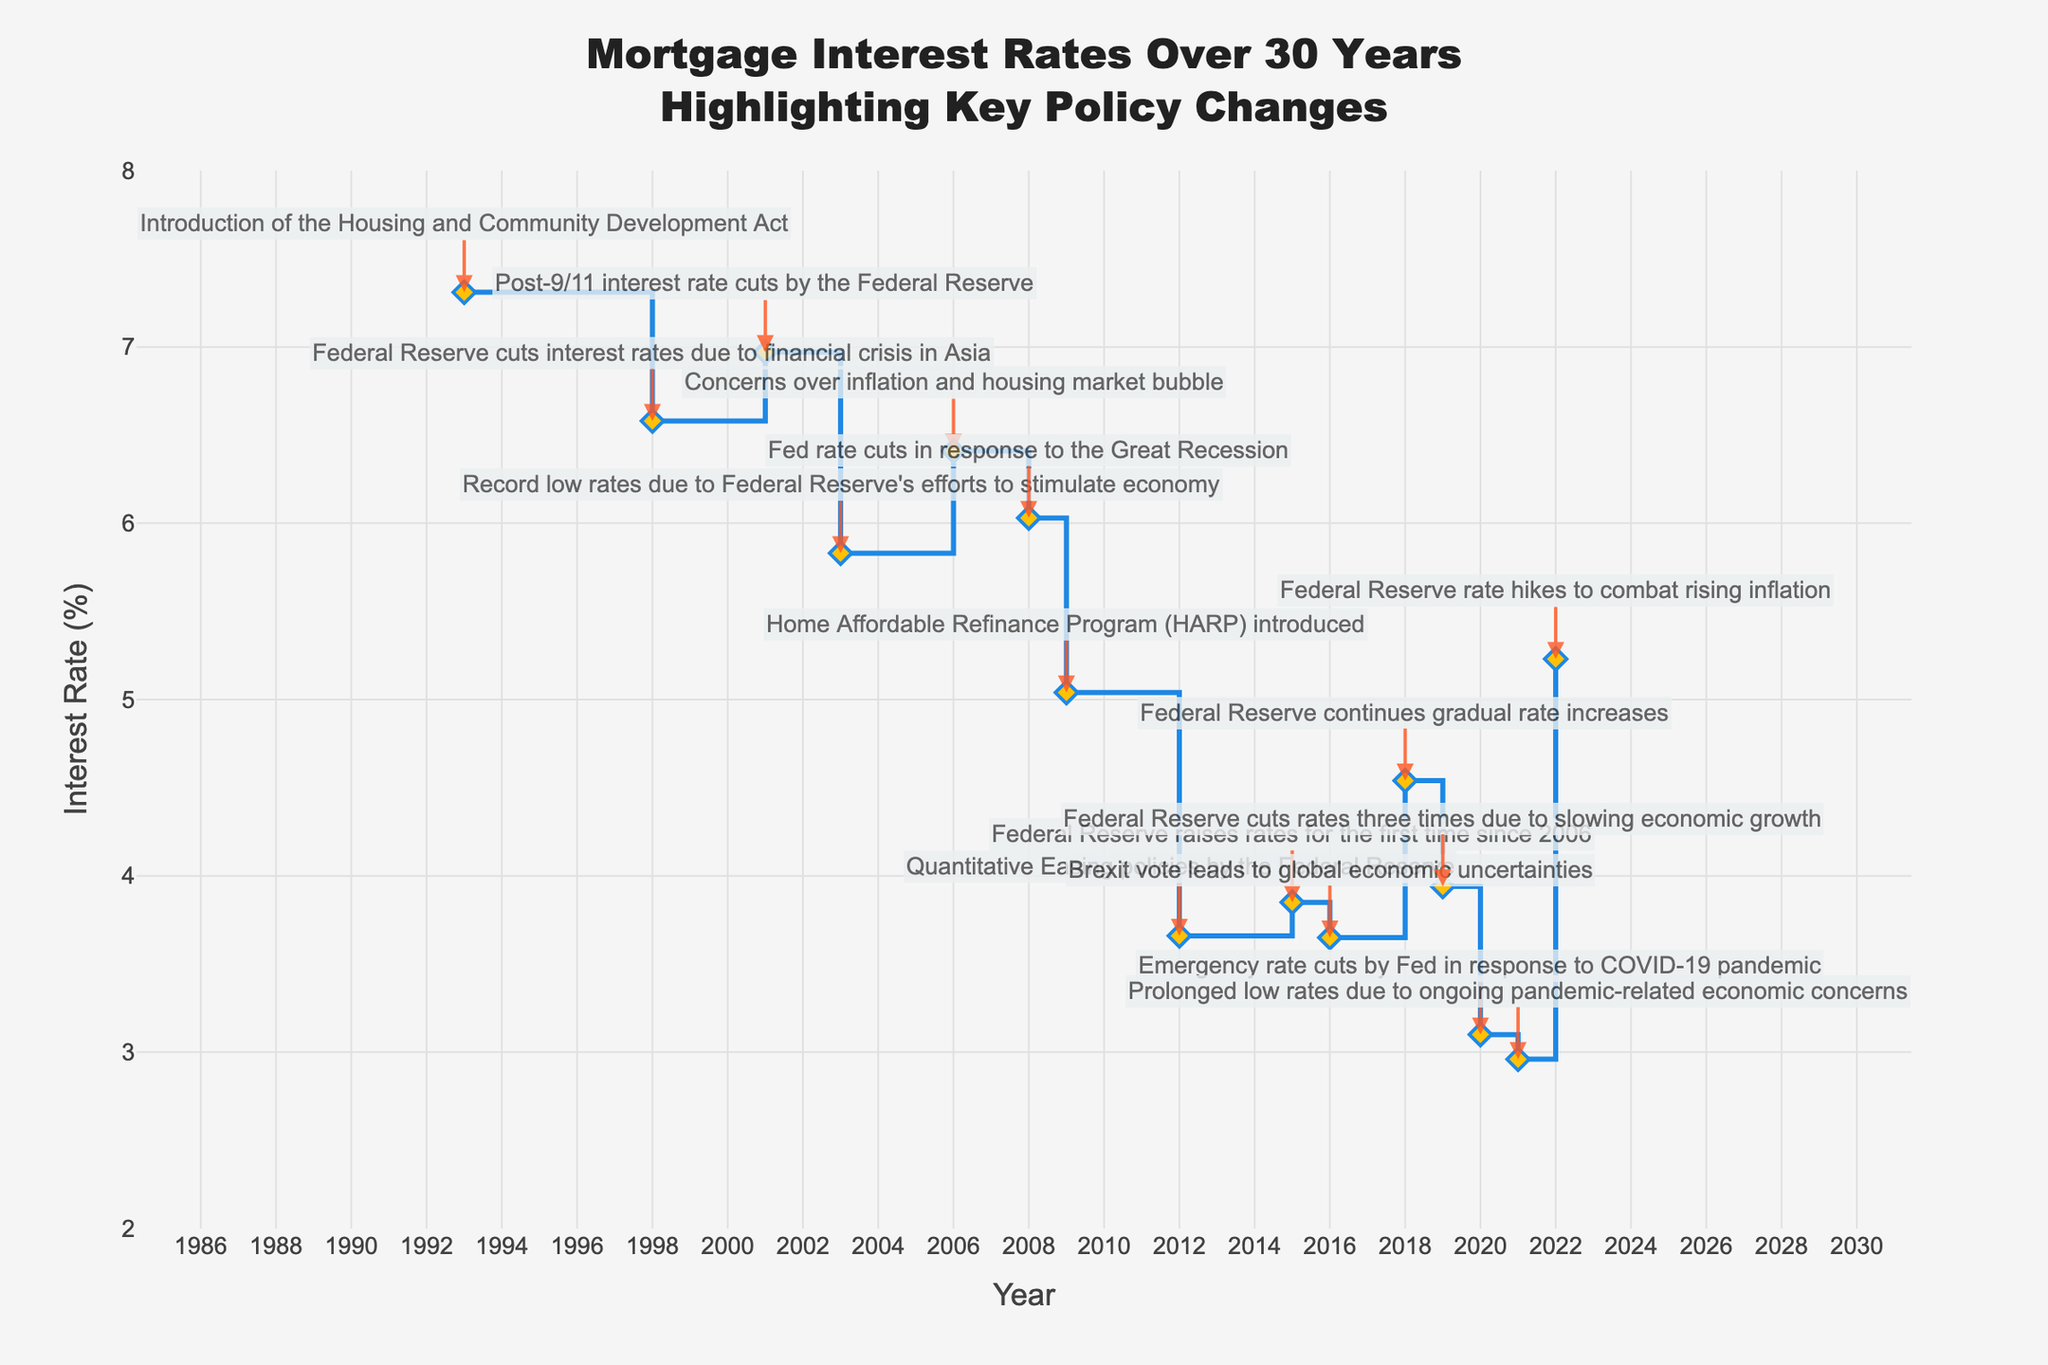What is the title of the figure? Look at the top of the figure to find the title. The title is written in a clear and large font for easy identification.
Answer: Mortgage Interest Rates Over 30 Years Highlighting Key Policy Changes What are the units of the y-axis? Check the label on the y-axis to identify the units used. The y-axis title mentions this information.
Answer: Percent (%) In which year did the interest rate reach its lowest point? Follow the line on the graph to find the lowest point, and check the corresponding year on the x-axis.
Answer: 2021 What color are the markers used for the interest rate data points? Look at the markers on the plotted line to observe their color and appearance.
Answer: Yellow What key policy change occurred in 2001? Find the annotation near the year 2001 on the plot and read the text indicated by the arrow.
Answer: Post-9/11 interest rate cuts by the Federal Reserve Between which years did the Federal Reserve implement Quantitative Easing policies, according to the figure? Look for the annotation indicating Quantitative Easing and identify the corresponding years on the x-axis.
Answer: 2012 How many times did the Federal Reserve cut rates in 2019? Find the annotation for the year 2019 and read the information provided by the text.
Answer: Three times Which event occurred in 2022 that led to a change in interest rates? Find the annotation near the year 2022 on the plot and read the text indicated by the arrow.
Answer: Federal Reserve rate hikes to combat rising inflation Compare the interest rate trends before and after the 2008 Great Recession. What differences can you identify? Check the interest rate trajectory leading up to 2008 and after 2008, noting changes in the slope and level of rates.
Answer: Rates decreased sharply after 2008 What was the approximate increase in the interest rate from 2021 to 2022? Look at the interest rates for 2021 and 2022 on the plot, then subtract the 2021 rate from the 2022 rate.
Answer: 2.27% 